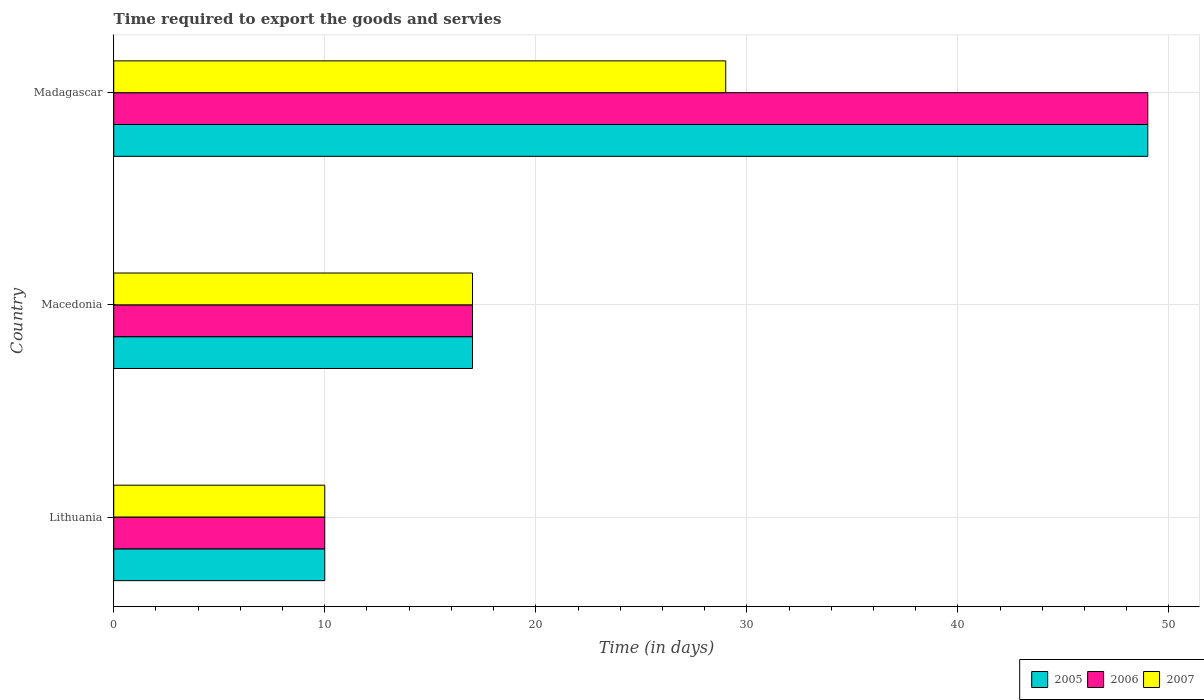How many groups of bars are there?
Offer a very short reply. 3. Are the number of bars per tick equal to the number of legend labels?
Offer a very short reply. Yes. How many bars are there on the 2nd tick from the top?
Give a very brief answer. 3. How many bars are there on the 1st tick from the bottom?
Offer a terse response. 3. What is the label of the 2nd group of bars from the top?
Provide a short and direct response. Macedonia. In how many cases, is the number of bars for a given country not equal to the number of legend labels?
Provide a succinct answer. 0. What is the number of days required to export the goods and services in 2007 in Macedonia?
Offer a terse response. 17. In which country was the number of days required to export the goods and services in 2006 maximum?
Keep it short and to the point. Madagascar. In which country was the number of days required to export the goods and services in 2007 minimum?
Your answer should be compact. Lithuania. What is the total number of days required to export the goods and services in 2006 in the graph?
Your response must be concise. 76. What is the difference between the number of days required to export the goods and services in 2005 in Macedonia and that in Madagascar?
Your answer should be compact. -32. What is the average number of days required to export the goods and services in 2005 per country?
Your answer should be compact. 25.33. What is the ratio of the number of days required to export the goods and services in 2007 in Lithuania to that in Madagascar?
Your answer should be compact. 0.34. Is the number of days required to export the goods and services in 2007 in Macedonia less than that in Madagascar?
Make the answer very short. Yes. Is the difference between the number of days required to export the goods and services in 2005 in Lithuania and Madagascar greater than the difference between the number of days required to export the goods and services in 2006 in Lithuania and Madagascar?
Ensure brevity in your answer.  No. What is the difference between the highest and the lowest number of days required to export the goods and services in 2006?
Your response must be concise. 39. In how many countries, is the number of days required to export the goods and services in 2007 greater than the average number of days required to export the goods and services in 2007 taken over all countries?
Ensure brevity in your answer.  1. Is the sum of the number of days required to export the goods and services in 2007 in Macedonia and Madagascar greater than the maximum number of days required to export the goods and services in 2005 across all countries?
Offer a terse response. No. What does the 2nd bar from the bottom in Madagascar represents?
Your answer should be compact. 2006. Is it the case that in every country, the sum of the number of days required to export the goods and services in 2007 and number of days required to export the goods and services in 2005 is greater than the number of days required to export the goods and services in 2006?
Your answer should be compact. Yes. Are all the bars in the graph horizontal?
Provide a succinct answer. Yes. How many legend labels are there?
Give a very brief answer. 3. What is the title of the graph?
Offer a terse response. Time required to export the goods and servies. What is the label or title of the X-axis?
Provide a succinct answer. Time (in days). What is the label or title of the Y-axis?
Your response must be concise. Country. What is the Time (in days) of 2005 in Lithuania?
Make the answer very short. 10. What is the Time (in days) of 2006 in Macedonia?
Your answer should be very brief. 17. What is the Time (in days) of 2006 in Madagascar?
Offer a very short reply. 49. What is the Time (in days) in 2007 in Madagascar?
Ensure brevity in your answer.  29. Across all countries, what is the maximum Time (in days) of 2005?
Your response must be concise. 49. Across all countries, what is the minimum Time (in days) of 2006?
Ensure brevity in your answer.  10. What is the total Time (in days) in 2005 in the graph?
Offer a very short reply. 76. What is the total Time (in days) in 2006 in the graph?
Your answer should be compact. 76. What is the difference between the Time (in days) of 2005 in Lithuania and that in Macedonia?
Offer a terse response. -7. What is the difference between the Time (in days) of 2006 in Lithuania and that in Macedonia?
Your answer should be very brief. -7. What is the difference between the Time (in days) of 2005 in Lithuania and that in Madagascar?
Your response must be concise. -39. What is the difference between the Time (in days) in 2006 in Lithuania and that in Madagascar?
Your answer should be very brief. -39. What is the difference between the Time (in days) of 2007 in Lithuania and that in Madagascar?
Your response must be concise. -19. What is the difference between the Time (in days) in 2005 in Macedonia and that in Madagascar?
Offer a terse response. -32. What is the difference between the Time (in days) in 2006 in Macedonia and that in Madagascar?
Make the answer very short. -32. What is the difference between the Time (in days) in 2007 in Macedonia and that in Madagascar?
Offer a terse response. -12. What is the difference between the Time (in days) of 2005 in Lithuania and the Time (in days) of 2006 in Macedonia?
Offer a terse response. -7. What is the difference between the Time (in days) of 2005 in Lithuania and the Time (in days) of 2007 in Macedonia?
Give a very brief answer. -7. What is the difference between the Time (in days) of 2006 in Lithuania and the Time (in days) of 2007 in Macedonia?
Ensure brevity in your answer.  -7. What is the difference between the Time (in days) of 2005 in Lithuania and the Time (in days) of 2006 in Madagascar?
Make the answer very short. -39. What is the difference between the Time (in days) of 2005 in Lithuania and the Time (in days) of 2007 in Madagascar?
Keep it short and to the point. -19. What is the difference between the Time (in days) in 2005 in Macedonia and the Time (in days) in 2006 in Madagascar?
Your response must be concise. -32. What is the difference between the Time (in days) in 2005 in Macedonia and the Time (in days) in 2007 in Madagascar?
Make the answer very short. -12. What is the difference between the Time (in days) in 2006 in Macedonia and the Time (in days) in 2007 in Madagascar?
Your answer should be very brief. -12. What is the average Time (in days) in 2005 per country?
Keep it short and to the point. 25.33. What is the average Time (in days) of 2006 per country?
Give a very brief answer. 25.33. What is the average Time (in days) in 2007 per country?
Provide a succinct answer. 18.67. What is the difference between the Time (in days) of 2005 and Time (in days) of 2007 in Lithuania?
Your answer should be compact. 0. What is the difference between the Time (in days) in 2006 and Time (in days) in 2007 in Macedonia?
Your response must be concise. 0. What is the difference between the Time (in days) of 2005 and Time (in days) of 2006 in Madagascar?
Offer a terse response. 0. What is the difference between the Time (in days) of 2006 and Time (in days) of 2007 in Madagascar?
Offer a very short reply. 20. What is the ratio of the Time (in days) in 2005 in Lithuania to that in Macedonia?
Give a very brief answer. 0.59. What is the ratio of the Time (in days) in 2006 in Lithuania to that in Macedonia?
Offer a terse response. 0.59. What is the ratio of the Time (in days) of 2007 in Lithuania to that in Macedonia?
Provide a succinct answer. 0.59. What is the ratio of the Time (in days) of 2005 in Lithuania to that in Madagascar?
Provide a succinct answer. 0.2. What is the ratio of the Time (in days) of 2006 in Lithuania to that in Madagascar?
Make the answer very short. 0.2. What is the ratio of the Time (in days) in 2007 in Lithuania to that in Madagascar?
Your answer should be compact. 0.34. What is the ratio of the Time (in days) in 2005 in Macedonia to that in Madagascar?
Ensure brevity in your answer.  0.35. What is the ratio of the Time (in days) of 2006 in Macedonia to that in Madagascar?
Keep it short and to the point. 0.35. What is the ratio of the Time (in days) in 2007 in Macedonia to that in Madagascar?
Provide a short and direct response. 0.59. What is the difference between the highest and the second highest Time (in days) of 2005?
Your answer should be compact. 32. What is the difference between the highest and the second highest Time (in days) in 2007?
Your response must be concise. 12. What is the difference between the highest and the lowest Time (in days) in 2006?
Ensure brevity in your answer.  39. What is the difference between the highest and the lowest Time (in days) of 2007?
Ensure brevity in your answer.  19. 